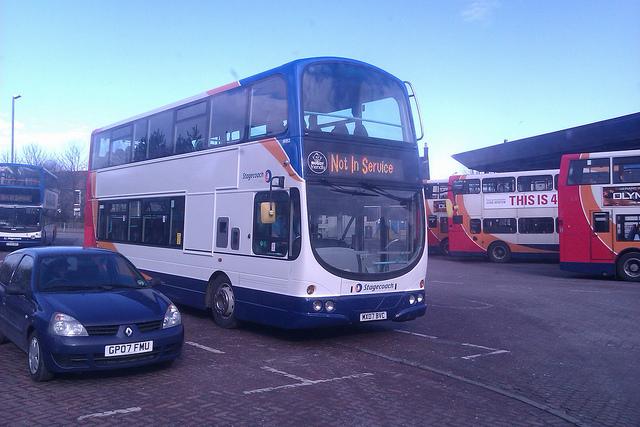What is the car sitting by?
Give a very brief answer. Bus. Are all the buses here painted the same?
Quick response, please. No. What time of year is this picture taken?
Keep it brief. Fall. What does the electronic sign say on the bus?
Concise answer only. Not in service. 